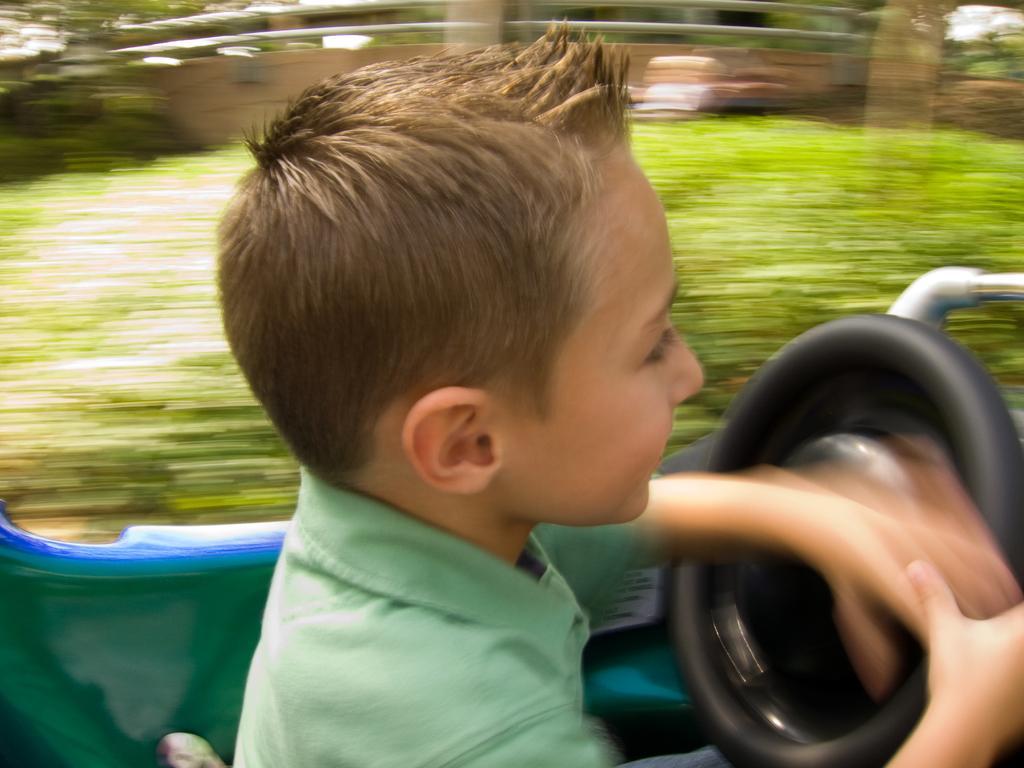Can you describe this image briefly? In this image we can see a boy sitting on a vehicle and holding the steering. The background is blurry. 